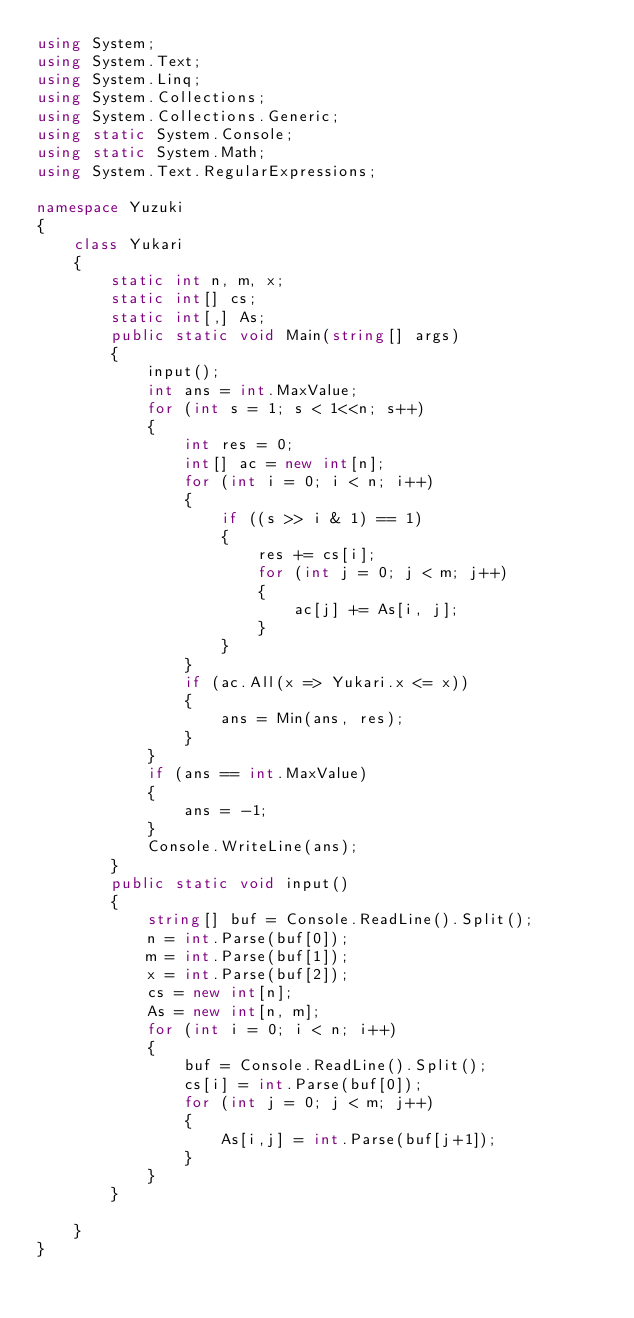<code> <loc_0><loc_0><loc_500><loc_500><_C#_>using System;
using System.Text;
using System.Linq;
using System.Collections;
using System.Collections.Generic;
using static System.Console;
using static System.Math;
using System.Text.RegularExpressions;

namespace Yuzuki
{
    class Yukari
    {
        static int n, m, x;
        static int[] cs;
        static int[,] As;
        public static void Main(string[] args)
        {
            input();
            int ans = int.MaxValue;
            for (int s = 1; s < 1<<n; s++)
            {
                int res = 0;
                int[] ac = new int[n];
                for (int i = 0; i < n; i++)
                {
                    if ((s >> i & 1) == 1)
                    {
                        res += cs[i];
                        for (int j = 0; j < m; j++)
                        {
                            ac[j] += As[i, j];
                        }
                    }
                }
                if (ac.All(x => Yukari.x <= x))
                {
                    ans = Min(ans, res);
                }
            }
            if (ans == int.MaxValue)
            {
                ans = -1;
            }
            Console.WriteLine(ans);
        }
        public static void input()
        {
            string[] buf = Console.ReadLine().Split();
            n = int.Parse(buf[0]);
            m = int.Parse(buf[1]);
            x = int.Parse(buf[2]);
            cs = new int[n];
            As = new int[n, m];
            for (int i = 0; i < n; i++)
            {
                buf = Console.ReadLine().Split();
                cs[i] = int.Parse(buf[0]);
                for (int j = 0; j < m; j++)
                {
                    As[i,j] = int.Parse(buf[j+1]);
                }
            }
        }

    }
}</code> 